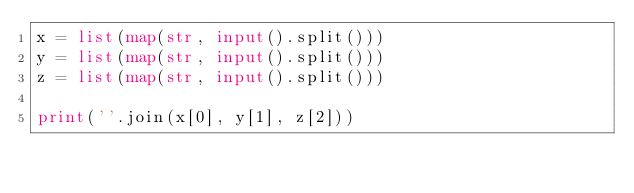<code> <loc_0><loc_0><loc_500><loc_500><_Python_>x = list(map(str, input().split()))
y = list(map(str, input().split()))
z = list(map(str, input().split()))

print(''.join(x[0], y[1], z[2]))</code> 